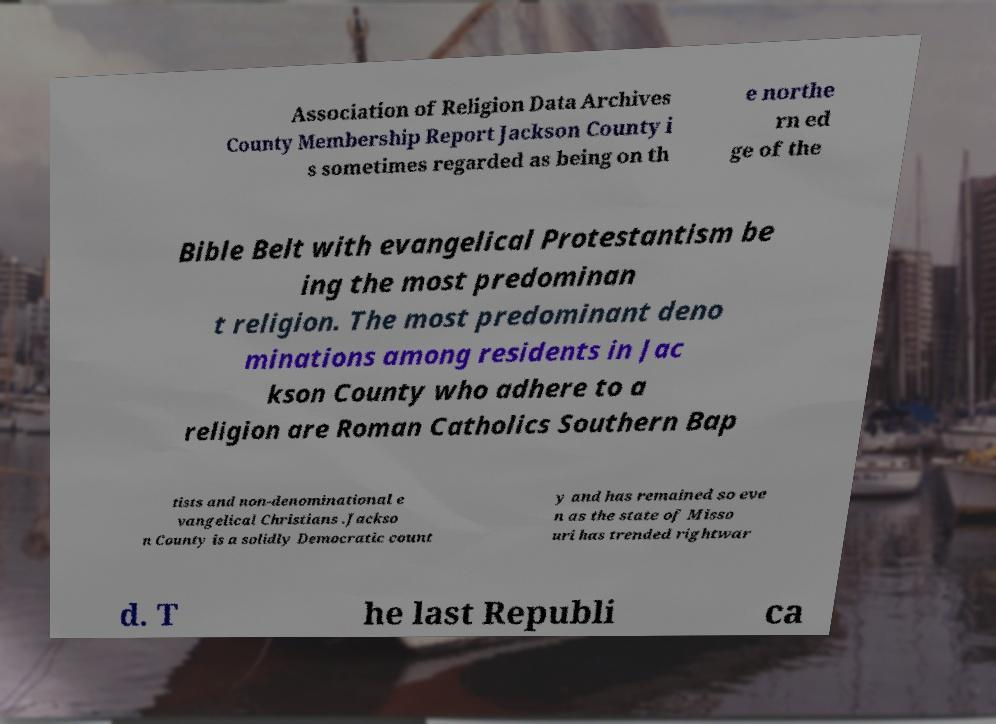Could you assist in decoding the text presented in this image and type it out clearly? Association of Religion Data Archives County Membership Report Jackson County i s sometimes regarded as being on th e northe rn ed ge of the Bible Belt with evangelical Protestantism be ing the most predominan t religion. The most predominant deno minations among residents in Jac kson County who adhere to a religion are Roman Catholics Southern Bap tists and non-denominational e vangelical Christians .Jackso n County is a solidly Democratic count y and has remained so eve n as the state of Misso uri has trended rightwar d. T he last Republi ca 